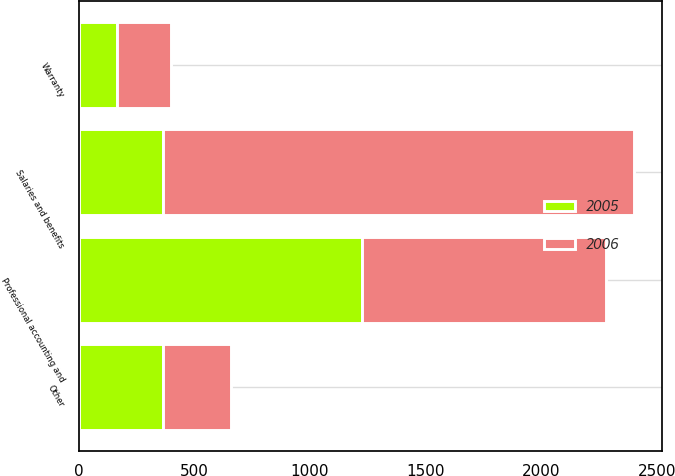<chart> <loc_0><loc_0><loc_500><loc_500><stacked_bar_chart><ecel><fcel>Salaries and benefits<fcel>Warranty<fcel>Professional accounting and<fcel>Other<nl><fcel>2006<fcel>2041<fcel>231<fcel>1057<fcel>294<nl><fcel>2005<fcel>362<fcel>167<fcel>1224<fcel>362<nl></chart> 